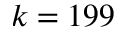<formula> <loc_0><loc_0><loc_500><loc_500>k = 1 9 9</formula> 